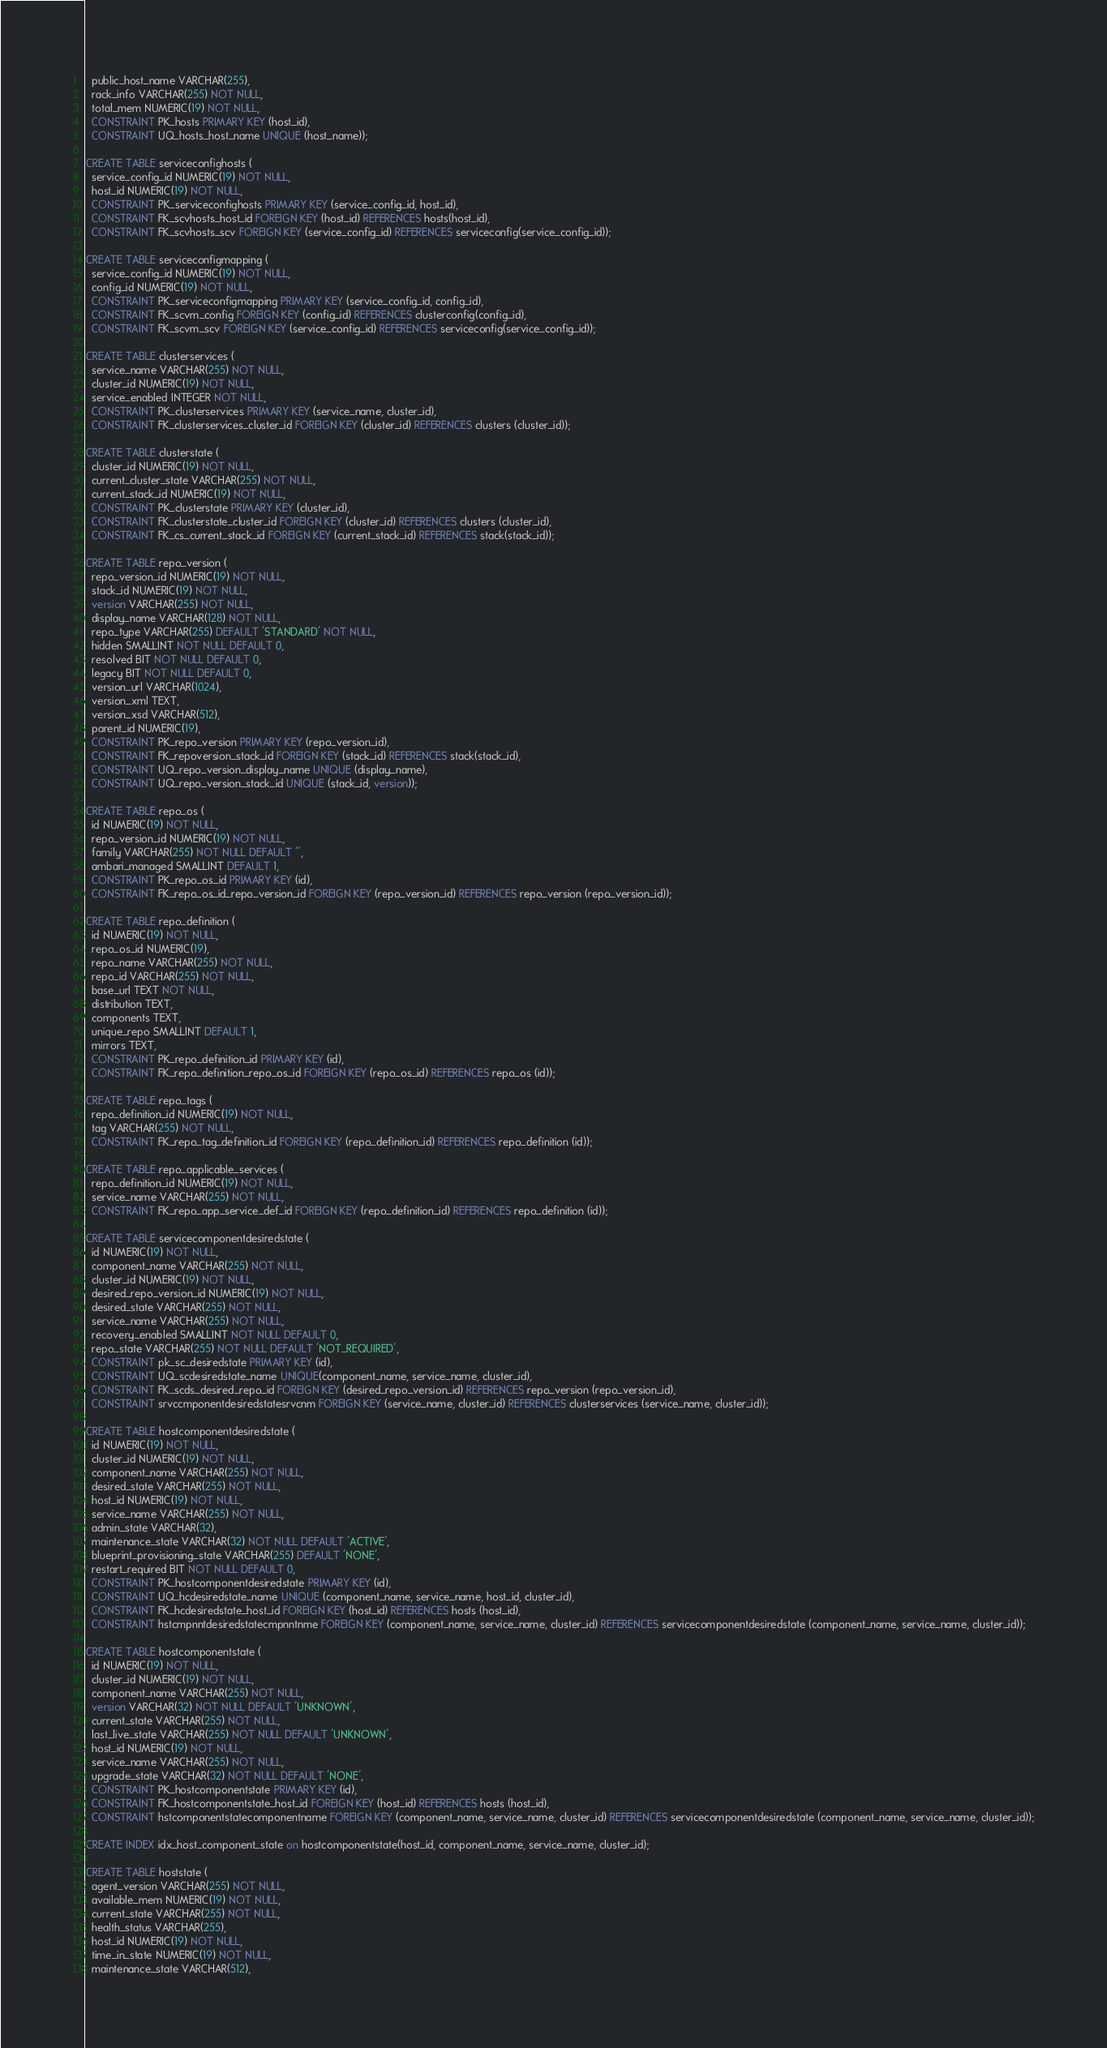<code> <loc_0><loc_0><loc_500><loc_500><_SQL_>  public_host_name VARCHAR(255),
  rack_info VARCHAR(255) NOT NULL,
  total_mem NUMERIC(19) NOT NULL,
  CONSTRAINT PK_hosts PRIMARY KEY (host_id),
  CONSTRAINT UQ_hosts_host_name UNIQUE (host_name));

CREATE TABLE serviceconfighosts (
  service_config_id NUMERIC(19) NOT NULL,
  host_id NUMERIC(19) NOT NULL,
  CONSTRAINT PK_serviceconfighosts PRIMARY KEY (service_config_id, host_id),
  CONSTRAINT FK_scvhosts_host_id FOREIGN KEY (host_id) REFERENCES hosts(host_id),
  CONSTRAINT FK_scvhosts_scv FOREIGN KEY (service_config_id) REFERENCES serviceconfig(service_config_id));

CREATE TABLE serviceconfigmapping (
  service_config_id NUMERIC(19) NOT NULL,
  config_id NUMERIC(19) NOT NULL,
  CONSTRAINT PK_serviceconfigmapping PRIMARY KEY (service_config_id, config_id),
  CONSTRAINT FK_scvm_config FOREIGN KEY (config_id) REFERENCES clusterconfig(config_id),
  CONSTRAINT FK_scvm_scv FOREIGN KEY (service_config_id) REFERENCES serviceconfig(service_config_id));

CREATE TABLE clusterservices (
  service_name VARCHAR(255) NOT NULL,
  cluster_id NUMERIC(19) NOT NULL,
  service_enabled INTEGER NOT NULL,
  CONSTRAINT PK_clusterservices PRIMARY KEY (service_name, cluster_id),
  CONSTRAINT FK_clusterservices_cluster_id FOREIGN KEY (cluster_id) REFERENCES clusters (cluster_id));

CREATE TABLE clusterstate (
  cluster_id NUMERIC(19) NOT NULL,
  current_cluster_state VARCHAR(255) NOT NULL,
  current_stack_id NUMERIC(19) NOT NULL,
  CONSTRAINT PK_clusterstate PRIMARY KEY (cluster_id),
  CONSTRAINT FK_clusterstate_cluster_id FOREIGN KEY (cluster_id) REFERENCES clusters (cluster_id),
  CONSTRAINT FK_cs_current_stack_id FOREIGN KEY (current_stack_id) REFERENCES stack(stack_id));

CREATE TABLE repo_version (
  repo_version_id NUMERIC(19) NOT NULL,
  stack_id NUMERIC(19) NOT NULL,
  version VARCHAR(255) NOT NULL,
  display_name VARCHAR(128) NOT NULL,
  repo_type VARCHAR(255) DEFAULT 'STANDARD' NOT NULL,
  hidden SMALLINT NOT NULL DEFAULT 0,
  resolved BIT NOT NULL DEFAULT 0,
  legacy BIT NOT NULL DEFAULT 0,
  version_url VARCHAR(1024),
  version_xml TEXT,
  version_xsd VARCHAR(512),
  parent_id NUMERIC(19),
  CONSTRAINT PK_repo_version PRIMARY KEY (repo_version_id),
  CONSTRAINT FK_repoversion_stack_id FOREIGN KEY (stack_id) REFERENCES stack(stack_id),
  CONSTRAINT UQ_repo_version_display_name UNIQUE (display_name),
  CONSTRAINT UQ_repo_version_stack_id UNIQUE (stack_id, version));

CREATE TABLE repo_os (
  id NUMERIC(19) NOT NULL,
  repo_version_id NUMERIC(19) NOT NULL,
  family VARCHAR(255) NOT NULL DEFAULT '',
  ambari_managed SMALLINT DEFAULT 1,
  CONSTRAINT PK_repo_os_id PRIMARY KEY (id),
  CONSTRAINT FK_repo_os_id_repo_version_id FOREIGN KEY (repo_version_id) REFERENCES repo_version (repo_version_id));

CREATE TABLE repo_definition (
  id NUMERIC(19) NOT NULL,
  repo_os_id NUMERIC(19),
  repo_name VARCHAR(255) NOT NULL,
  repo_id VARCHAR(255) NOT NULL,
  base_url TEXT NOT NULL,
  distribution TEXT,
  components TEXT,
  unique_repo SMALLINT DEFAULT 1,
  mirrors TEXT,
  CONSTRAINT PK_repo_definition_id PRIMARY KEY (id),
  CONSTRAINT FK_repo_definition_repo_os_id FOREIGN KEY (repo_os_id) REFERENCES repo_os (id));

CREATE TABLE repo_tags (
  repo_definition_id NUMERIC(19) NOT NULL,
  tag VARCHAR(255) NOT NULL,
  CONSTRAINT FK_repo_tag_definition_id FOREIGN KEY (repo_definition_id) REFERENCES repo_definition (id));

CREATE TABLE repo_applicable_services (
  repo_definition_id NUMERIC(19) NOT NULL,
  service_name VARCHAR(255) NOT NULL,
  CONSTRAINT FK_repo_app_service_def_id FOREIGN KEY (repo_definition_id) REFERENCES repo_definition (id));

CREATE TABLE servicecomponentdesiredstate (
  id NUMERIC(19) NOT NULL,
  component_name VARCHAR(255) NOT NULL,
  cluster_id NUMERIC(19) NOT NULL,
  desired_repo_version_id NUMERIC(19) NOT NULL,
  desired_state VARCHAR(255) NOT NULL,
  service_name VARCHAR(255) NOT NULL,
  recovery_enabled SMALLINT NOT NULL DEFAULT 0,
  repo_state VARCHAR(255) NOT NULL DEFAULT 'NOT_REQUIRED',
  CONSTRAINT pk_sc_desiredstate PRIMARY KEY (id),
  CONSTRAINT UQ_scdesiredstate_name UNIQUE(component_name, service_name, cluster_id),
  CONSTRAINT FK_scds_desired_repo_id FOREIGN KEY (desired_repo_version_id) REFERENCES repo_version (repo_version_id),
  CONSTRAINT srvccmponentdesiredstatesrvcnm FOREIGN KEY (service_name, cluster_id) REFERENCES clusterservices (service_name, cluster_id));

CREATE TABLE hostcomponentdesiredstate (
  id NUMERIC(19) NOT NULL,
  cluster_id NUMERIC(19) NOT NULL,
  component_name VARCHAR(255) NOT NULL,
  desired_state VARCHAR(255) NOT NULL,
  host_id NUMERIC(19) NOT NULL,
  service_name VARCHAR(255) NOT NULL,
  admin_state VARCHAR(32),
  maintenance_state VARCHAR(32) NOT NULL DEFAULT 'ACTIVE',
  blueprint_provisioning_state VARCHAR(255) DEFAULT 'NONE',
  restart_required BIT NOT NULL DEFAULT 0,
  CONSTRAINT PK_hostcomponentdesiredstate PRIMARY KEY (id),
  CONSTRAINT UQ_hcdesiredstate_name UNIQUE (component_name, service_name, host_id, cluster_id),
  CONSTRAINT FK_hcdesiredstate_host_id FOREIGN KEY (host_id) REFERENCES hosts (host_id),
  CONSTRAINT hstcmpnntdesiredstatecmpnntnme FOREIGN KEY (component_name, service_name, cluster_id) REFERENCES servicecomponentdesiredstate (component_name, service_name, cluster_id));

CREATE TABLE hostcomponentstate (
  id NUMERIC(19) NOT NULL,
  cluster_id NUMERIC(19) NOT NULL,
  component_name VARCHAR(255) NOT NULL,
  version VARCHAR(32) NOT NULL DEFAULT 'UNKNOWN',
  current_state VARCHAR(255) NOT NULL,
  last_live_state VARCHAR(255) NOT NULL DEFAULT 'UNKNOWN',
  host_id NUMERIC(19) NOT NULL,
  service_name VARCHAR(255) NOT NULL,
  upgrade_state VARCHAR(32) NOT NULL DEFAULT 'NONE',
  CONSTRAINT PK_hostcomponentstate PRIMARY KEY (id),
  CONSTRAINT FK_hostcomponentstate_host_id FOREIGN KEY (host_id) REFERENCES hosts (host_id),
  CONSTRAINT hstcomponentstatecomponentname FOREIGN KEY (component_name, service_name, cluster_id) REFERENCES servicecomponentdesiredstate (component_name, service_name, cluster_id));

CREATE INDEX idx_host_component_state on hostcomponentstate(host_id, component_name, service_name, cluster_id);

CREATE TABLE hoststate (
  agent_version VARCHAR(255) NOT NULL,
  available_mem NUMERIC(19) NOT NULL,
  current_state VARCHAR(255) NOT NULL,
  health_status VARCHAR(255),
  host_id NUMERIC(19) NOT NULL,
  time_in_state NUMERIC(19) NOT NULL,
  maintenance_state VARCHAR(512),</code> 